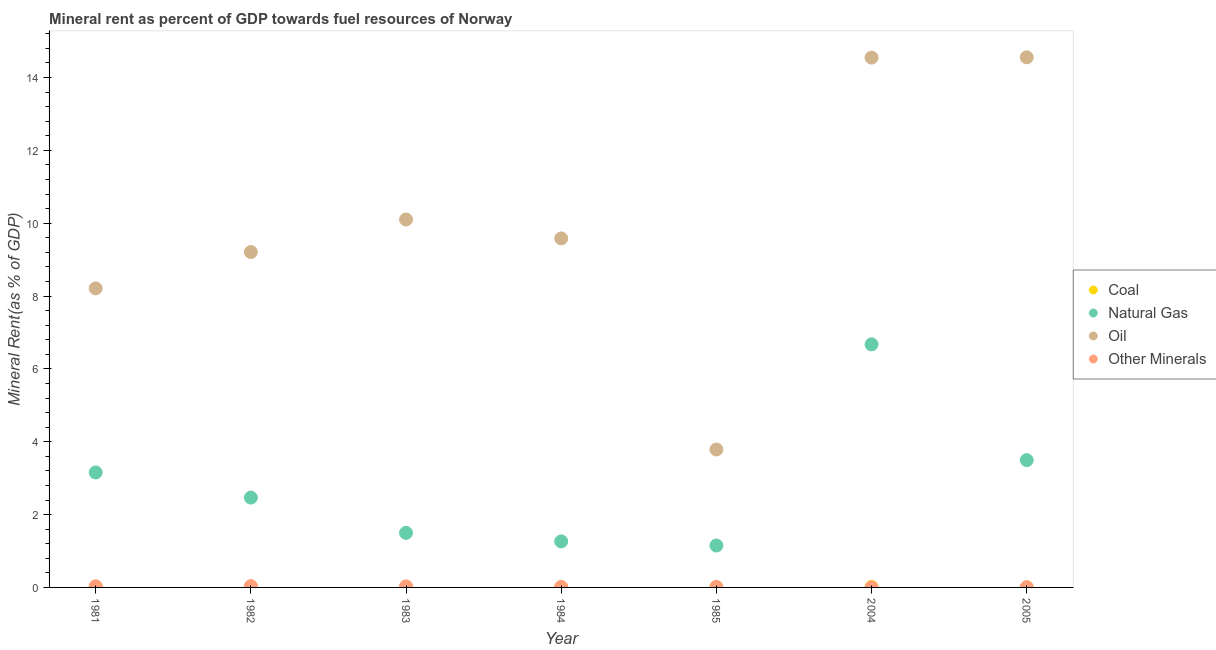What is the coal rent in 1982?
Give a very brief answer. 0.02. Across all years, what is the maximum  rent of other minerals?
Provide a succinct answer. 0.04. Across all years, what is the minimum  rent of other minerals?
Keep it short and to the point. 0. What is the total oil rent in the graph?
Ensure brevity in your answer.  70. What is the difference between the oil rent in 1981 and that in 1984?
Your answer should be very brief. -1.37. What is the difference between the coal rent in 1985 and the  rent of other minerals in 1982?
Give a very brief answer. -0.03. What is the average  rent of other minerals per year?
Ensure brevity in your answer.  0.02. In the year 2004, what is the difference between the oil rent and  rent of other minerals?
Your answer should be compact. 14.55. What is the ratio of the oil rent in 1981 to that in 1984?
Your response must be concise. 0.86. What is the difference between the highest and the second highest  rent of other minerals?
Make the answer very short. 0. What is the difference between the highest and the lowest coal rent?
Offer a terse response. 0.02. In how many years, is the natural gas rent greater than the average natural gas rent taken over all years?
Provide a short and direct response. 3. Is the sum of the natural gas rent in 2004 and 2005 greater than the maximum oil rent across all years?
Your response must be concise. No. Is it the case that in every year, the sum of the  rent of other minerals and natural gas rent is greater than the sum of coal rent and oil rent?
Provide a succinct answer. Yes. Is it the case that in every year, the sum of the coal rent and natural gas rent is greater than the oil rent?
Provide a short and direct response. No. Is the coal rent strictly greater than the natural gas rent over the years?
Provide a succinct answer. No. Is the oil rent strictly less than the natural gas rent over the years?
Give a very brief answer. No. Are the values on the major ticks of Y-axis written in scientific E-notation?
Provide a short and direct response. No. Does the graph contain any zero values?
Make the answer very short. No. Where does the legend appear in the graph?
Ensure brevity in your answer.  Center right. How many legend labels are there?
Give a very brief answer. 4. How are the legend labels stacked?
Offer a very short reply. Vertical. What is the title of the graph?
Your answer should be very brief. Mineral rent as percent of GDP towards fuel resources of Norway. Does "Salary of employees" appear as one of the legend labels in the graph?
Your answer should be compact. No. What is the label or title of the X-axis?
Give a very brief answer. Year. What is the label or title of the Y-axis?
Provide a short and direct response. Mineral Rent(as % of GDP). What is the Mineral Rent(as % of GDP) of Coal in 1981?
Keep it short and to the point. 0.01. What is the Mineral Rent(as % of GDP) in Natural Gas in 1981?
Your answer should be compact. 3.16. What is the Mineral Rent(as % of GDP) of Oil in 1981?
Offer a terse response. 8.21. What is the Mineral Rent(as % of GDP) of Other Minerals in 1981?
Your response must be concise. 0.03. What is the Mineral Rent(as % of GDP) of Coal in 1982?
Your answer should be very brief. 0.02. What is the Mineral Rent(as % of GDP) of Natural Gas in 1982?
Your answer should be very brief. 2.47. What is the Mineral Rent(as % of GDP) in Oil in 1982?
Ensure brevity in your answer.  9.21. What is the Mineral Rent(as % of GDP) in Other Minerals in 1982?
Provide a succinct answer. 0.04. What is the Mineral Rent(as % of GDP) in Coal in 1983?
Your answer should be very brief. 0. What is the Mineral Rent(as % of GDP) in Natural Gas in 1983?
Ensure brevity in your answer.  1.5. What is the Mineral Rent(as % of GDP) in Oil in 1983?
Make the answer very short. 10.1. What is the Mineral Rent(as % of GDP) of Other Minerals in 1983?
Offer a terse response. 0.03. What is the Mineral Rent(as % of GDP) of Coal in 1984?
Provide a succinct answer. 0. What is the Mineral Rent(as % of GDP) of Natural Gas in 1984?
Make the answer very short. 1.26. What is the Mineral Rent(as % of GDP) of Oil in 1984?
Your answer should be compact. 9.58. What is the Mineral Rent(as % of GDP) of Other Minerals in 1984?
Give a very brief answer. 0.02. What is the Mineral Rent(as % of GDP) of Coal in 1985?
Provide a short and direct response. 0. What is the Mineral Rent(as % of GDP) in Natural Gas in 1985?
Ensure brevity in your answer.  1.15. What is the Mineral Rent(as % of GDP) in Oil in 1985?
Your answer should be very brief. 3.79. What is the Mineral Rent(as % of GDP) in Other Minerals in 1985?
Your answer should be compact. 0.01. What is the Mineral Rent(as % of GDP) in Coal in 2004?
Make the answer very short. 0.01. What is the Mineral Rent(as % of GDP) of Natural Gas in 2004?
Provide a succinct answer. 6.67. What is the Mineral Rent(as % of GDP) in Oil in 2004?
Provide a short and direct response. 14.55. What is the Mineral Rent(as % of GDP) in Other Minerals in 2004?
Provide a succinct answer. 0. What is the Mineral Rent(as % of GDP) in Coal in 2005?
Provide a succinct answer. 0. What is the Mineral Rent(as % of GDP) of Natural Gas in 2005?
Offer a very short reply. 3.49. What is the Mineral Rent(as % of GDP) of Oil in 2005?
Your answer should be compact. 14.56. What is the Mineral Rent(as % of GDP) of Other Minerals in 2005?
Your response must be concise. 0.01. Across all years, what is the maximum Mineral Rent(as % of GDP) in Coal?
Provide a succinct answer. 0.02. Across all years, what is the maximum Mineral Rent(as % of GDP) of Natural Gas?
Ensure brevity in your answer.  6.67. Across all years, what is the maximum Mineral Rent(as % of GDP) of Oil?
Provide a succinct answer. 14.56. Across all years, what is the maximum Mineral Rent(as % of GDP) in Other Minerals?
Offer a very short reply. 0.04. Across all years, what is the minimum Mineral Rent(as % of GDP) in Coal?
Ensure brevity in your answer.  0. Across all years, what is the minimum Mineral Rent(as % of GDP) in Natural Gas?
Make the answer very short. 1.15. Across all years, what is the minimum Mineral Rent(as % of GDP) of Oil?
Your answer should be compact. 3.79. Across all years, what is the minimum Mineral Rent(as % of GDP) of Other Minerals?
Your response must be concise. 0. What is the total Mineral Rent(as % of GDP) of Coal in the graph?
Make the answer very short. 0.05. What is the total Mineral Rent(as % of GDP) in Natural Gas in the graph?
Keep it short and to the point. 19.71. What is the total Mineral Rent(as % of GDP) of Oil in the graph?
Keep it short and to the point. 70. What is the total Mineral Rent(as % of GDP) in Other Minerals in the graph?
Make the answer very short. 0.14. What is the difference between the Mineral Rent(as % of GDP) in Coal in 1981 and that in 1982?
Your answer should be compact. -0. What is the difference between the Mineral Rent(as % of GDP) of Natural Gas in 1981 and that in 1982?
Make the answer very short. 0.69. What is the difference between the Mineral Rent(as % of GDP) in Oil in 1981 and that in 1982?
Offer a very short reply. -1. What is the difference between the Mineral Rent(as % of GDP) of Other Minerals in 1981 and that in 1982?
Ensure brevity in your answer.  -0.01. What is the difference between the Mineral Rent(as % of GDP) of Coal in 1981 and that in 1983?
Offer a terse response. 0.01. What is the difference between the Mineral Rent(as % of GDP) of Natural Gas in 1981 and that in 1983?
Your answer should be very brief. 1.66. What is the difference between the Mineral Rent(as % of GDP) in Oil in 1981 and that in 1983?
Offer a terse response. -1.89. What is the difference between the Mineral Rent(as % of GDP) in Other Minerals in 1981 and that in 1983?
Ensure brevity in your answer.  0. What is the difference between the Mineral Rent(as % of GDP) of Coal in 1981 and that in 1984?
Keep it short and to the point. 0.01. What is the difference between the Mineral Rent(as % of GDP) of Natural Gas in 1981 and that in 1984?
Your answer should be compact. 1.89. What is the difference between the Mineral Rent(as % of GDP) in Oil in 1981 and that in 1984?
Keep it short and to the point. -1.37. What is the difference between the Mineral Rent(as % of GDP) of Other Minerals in 1981 and that in 1984?
Your answer should be very brief. 0.02. What is the difference between the Mineral Rent(as % of GDP) of Coal in 1981 and that in 1985?
Your answer should be compact. 0.01. What is the difference between the Mineral Rent(as % of GDP) in Natural Gas in 1981 and that in 1985?
Your response must be concise. 2.01. What is the difference between the Mineral Rent(as % of GDP) in Oil in 1981 and that in 1985?
Your answer should be compact. 4.42. What is the difference between the Mineral Rent(as % of GDP) in Other Minerals in 1981 and that in 1985?
Offer a very short reply. 0.02. What is the difference between the Mineral Rent(as % of GDP) of Coal in 1981 and that in 2004?
Provide a succinct answer. -0. What is the difference between the Mineral Rent(as % of GDP) in Natural Gas in 1981 and that in 2004?
Provide a succinct answer. -3.52. What is the difference between the Mineral Rent(as % of GDP) of Oil in 1981 and that in 2004?
Your response must be concise. -6.34. What is the difference between the Mineral Rent(as % of GDP) in Other Minerals in 1981 and that in 2004?
Offer a terse response. 0.03. What is the difference between the Mineral Rent(as % of GDP) in Coal in 1981 and that in 2005?
Ensure brevity in your answer.  0.01. What is the difference between the Mineral Rent(as % of GDP) of Natural Gas in 1981 and that in 2005?
Give a very brief answer. -0.34. What is the difference between the Mineral Rent(as % of GDP) of Oil in 1981 and that in 2005?
Provide a succinct answer. -6.34. What is the difference between the Mineral Rent(as % of GDP) in Other Minerals in 1981 and that in 2005?
Give a very brief answer. 0.03. What is the difference between the Mineral Rent(as % of GDP) of Coal in 1982 and that in 1983?
Your answer should be compact. 0.01. What is the difference between the Mineral Rent(as % of GDP) of Natural Gas in 1982 and that in 1983?
Your answer should be very brief. 0.97. What is the difference between the Mineral Rent(as % of GDP) of Oil in 1982 and that in 1983?
Your response must be concise. -0.89. What is the difference between the Mineral Rent(as % of GDP) of Other Minerals in 1982 and that in 1983?
Keep it short and to the point. 0.01. What is the difference between the Mineral Rent(as % of GDP) in Coal in 1982 and that in 1984?
Provide a succinct answer. 0.02. What is the difference between the Mineral Rent(as % of GDP) of Natural Gas in 1982 and that in 1984?
Offer a terse response. 1.2. What is the difference between the Mineral Rent(as % of GDP) in Oil in 1982 and that in 1984?
Offer a terse response. -0.37. What is the difference between the Mineral Rent(as % of GDP) in Other Minerals in 1982 and that in 1984?
Ensure brevity in your answer.  0.02. What is the difference between the Mineral Rent(as % of GDP) in Coal in 1982 and that in 1985?
Offer a terse response. 0.01. What is the difference between the Mineral Rent(as % of GDP) of Natural Gas in 1982 and that in 1985?
Your response must be concise. 1.32. What is the difference between the Mineral Rent(as % of GDP) of Oil in 1982 and that in 1985?
Ensure brevity in your answer.  5.42. What is the difference between the Mineral Rent(as % of GDP) in Other Minerals in 1982 and that in 1985?
Keep it short and to the point. 0.02. What is the difference between the Mineral Rent(as % of GDP) in Natural Gas in 1982 and that in 2004?
Keep it short and to the point. -4.21. What is the difference between the Mineral Rent(as % of GDP) in Oil in 1982 and that in 2004?
Make the answer very short. -5.34. What is the difference between the Mineral Rent(as % of GDP) of Other Minerals in 1982 and that in 2004?
Make the answer very short. 0.04. What is the difference between the Mineral Rent(as % of GDP) of Coal in 1982 and that in 2005?
Give a very brief answer. 0.01. What is the difference between the Mineral Rent(as % of GDP) of Natural Gas in 1982 and that in 2005?
Make the answer very short. -1.03. What is the difference between the Mineral Rent(as % of GDP) in Oil in 1982 and that in 2005?
Give a very brief answer. -5.35. What is the difference between the Mineral Rent(as % of GDP) in Other Minerals in 1982 and that in 2005?
Offer a terse response. 0.03. What is the difference between the Mineral Rent(as % of GDP) of Coal in 1983 and that in 1984?
Your answer should be very brief. 0. What is the difference between the Mineral Rent(as % of GDP) of Natural Gas in 1983 and that in 1984?
Make the answer very short. 0.23. What is the difference between the Mineral Rent(as % of GDP) of Oil in 1983 and that in 1984?
Provide a short and direct response. 0.52. What is the difference between the Mineral Rent(as % of GDP) in Other Minerals in 1983 and that in 1984?
Offer a terse response. 0.01. What is the difference between the Mineral Rent(as % of GDP) of Coal in 1983 and that in 1985?
Provide a short and direct response. 0. What is the difference between the Mineral Rent(as % of GDP) of Natural Gas in 1983 and that in 1985?
Give a very brief answer. 0.35. What is the difference between the Mineral Rent(as % of GDP) of Oil in 1983 and that in 1985?
Ensure brevity in your answer.  6.32. What is the difference between the Mineral Rent(as % of GDP) in Other Minerals in 1983 and that in 1985?
Ensure brevity in your answer.  0.01. What is the difference between the Mineral Rent(as % of GDP) in Coal in 1983 and that in 2004?
Your response must be concise. -0.01. What is the difference between the Mineral Rent(as % of GDP) of Natural Gas in 1983 and that in 2004?
Offer a terse response. -5.18. What is the difference between the Mineral Rent(as % of GDP) of Oil in 1983 and that in 2004?
Keep it short and to the point. -4.45. What is the difference between the Mineral Rent(as % of GDP) of Other Minerals in 1983 and that in 2004?
Give a very brief answer. 0.03. What is the difference between the Mineral Rent(as % of GDP) in Coal in 1983 and that in 2005?
Provide a short and direct response. 0. What is the difference between the Mineral Rent(as % of GDP) in Natural Gas in 1983 and that in 2005?
Provide a short and direct response. -2. What is the difference between the Mineral Rent(as % of GDP) of Oil in 1983 and that in 2005?
Offer a very short reply. -4.45. What is the difference between the Mineral Rent(as % of GDP) of Other Minerals in 1983 and that in 2005?
Ensure brevity in your answer.  0.02. What is the difference between the Mineral Rent(as % of GDP) in Coal in 1984 and that in 1985?
Give a very brief answer. -0. What is the difference between the Mineral Rent(as % of GDP) of Natural Gas in 1984 and that in 1985?
Provide a succinct answer. 0.11. What is the difference between the Mineral Rent(as % of GDP) of Oil in 1984 and that in 1985?
Ensure brevity in your answer.  5.8. What is the difference between the Mineral Rent(as % of GDP) in Other Minerals in 1984 and that in 1985?
Make the answer very short. 0. What is the difference between the Mineral Rent(as % of GDP) of Coal in 1984 and that in 2004?
Offer a terse response. -0.01. What is the difference between the Mineral Rent(as % of GDP) in Natural Gas in 1984 and that in 2004?
Give a very brief answer. -5.41. What is the difference between the Mineral Rent(as % of GDP) of Oil in 1984 and that in 2004?
Your response must be concise. -4.97. What is the difference between the Mineral Rent(as % of GDP) in Other Minerals in 1984 and that in 2004?
Give a very brief answer. 0.02. What is the difference between the Mineral Rent(as % of GDP) in Coal in 1984 and that in 2005?
Your answer should be compact. -0. What is the difference between the Mineral Rent(as % of GDP) of Natural Gas in 1984 and that in 2005?
Keep it short and to the point. -2.23. What is the difference between the Mineral Rent(as % of GDP) in Oil in 1984 and that in 2005?
Your response must be concise. -4.97. What is the difference between the Mineral Rent(as % of GDP) in Other Minerals in 1984 and that in 2005?
Keep it short and to the point. 0.01. What is the difference between the Mineral Rent(as % of GDP) in Coal in 1985 and that in 2004?
Provide a succinct answer. -0.01. What is the difference between the Mineral Rent(as % of GDP) of Natural Gas in 1985 and that in 2004?
Provide a succinct answer. -5.52. What is the difference between the Mineral Rent(as % of GDP) in Oil in 1985 and that in 2004?
Offer a terse response. -10.76. What is the difference between the Mineral Rent(as % of GDP) in Other Minerals in 1985 and that in 2004?
Give a very brief answer. 0.01. What is the difference between the Mineral Rent(as % of GDP) of Coal in 1985 and that in 2005?
Your response must be concise. 0. What is the difference between the Mineral Rent(as % of GDP) of Natural Gas in 1985 and that in 2005?
Make the answer very short. -2.34. What is the difference between the Mineral Rent(as % of GDP) of Oil in 1985 and that in 2005?
Offer a terse response. -10.77. What is the difference between the Mineral Rent(as % of GDP) in Other Minerals in 1985 and that in 2005?
Offer a very short reply. 0.01. What is the difference between the Mineral Rent(as % of GDP) of Coal in 2004 and that in 2005?
Your answer should be very brief. 0.01. What is the difference between the Mineral Rent(as % of GDP) in Natural Gas in 2004 and that in 2005?
Your response must be concise. 3.18. What is the difference between the Mineral Rent(as % of GDP) of Oil in 2004 and that in 2005?
Offer a very short reply. -0.01. What is the difference between the Mineral Rent(as % of GDP) in Other Minerals in 2004 and that in 2005?
Make the answer very short. -0.01. What is the difference between the Mineral Rent(as % of GDP) in Coal in 1981 and the Mineral Rent(as % of GDP) in Natural Gas in 1982?
Offer a terse response. -2.45. What is the difference between the Mineral Rent(as % of GDP) in Coal in 1981 and the Mineral Rent(as % of GDP) in Oil in 1982?
Your answer should be very brief. -9.2. What is the difference between the Mineral Rent(as % of GDP) in Coal in 1981 and the Mineral Rent(as % of GDP) in Other Minerals in 1982?
Provide a succinct answer. -0.02. What is the difference between the Mineral Rent(as % of GDP) in Natural Gas in 1981 and the Mineral Rent(as % of GDP) in Oil in 1982?
Your answer should be very brief. -6.05. What is the difference between the Mineral Rent(as % of GDP) in Natural Gas in 1981 and the Mineral Rent(as % of GDP) in Other Minerals in 1982?
Ensure brevity in your answer.  3.12. What is the difference between the Mineral Rent(as % of GDP) in Oil in 1981 and the Mineral Rent(as % of GDP) in Other Minerals in 1982?
Give a very brief answer. 8.17. What is the difference between the Mineral Rent(as % of GDP) in Coal in 1981 and the Mineral Rent(as % of GDP) in Natural Gas in 1983?
Ensure brevity in your answer.  -1.49. What is the difference between the Mineral Rent(as % of GDP) in Coal in 1981 and the Mineral Rent(as % of GDP) in Oil in 1983?
Your answer should be very brief. -10.09. What is the difference between the Mineral Rent(as % of GDP) of Coal in 1981 and the Mineral Rent(as % of GDP) of Other Minerals in 1983?
Keep it short and to the point. -0.02. What is the difference between the Mineral Rent(as % of GDP) in Natural Gas in 1981 and the Mineral Rent(as % of GDP) in Oil in 1983?
Provide a succinct answer. -6.95. What is the difference between the Mineral Rent(as % of GDP) in Natural Gas in 1981 and the Mineral Rent(as % of GDP) in Other Minerals in 1983?
Offer a very short reply. 3.13. What is the difference between the Mineral Rent(as % of GDP) in Oil in 1981 and the Mineral Rent(as % of GDP) in Other Minerals in 1983?
Ensure brevity in your answer.  8.18. What is the difference between the Mineral Rent(as % of GDP) in Coal in 1981 and the Mineral Rent(as % of GDP) in Natural Gas in 1984?
Provide a succinct answer. -1.25. What is the difference between the Mineral Rent(as % of GDP) of Coal in 1981 and the Mineral Rent(as % of GDP) of Oil in 1984?
Make the answer very short. -9.57. What is the difference between the Mineral Rent(as % of GDP) of Coal in 1981 and the Mineral Rent(as % of GDP) of Other Minerals in 1984?
Your answer should be very brief. -0. What is the difference between the Mineral Rent(as % of GDP) in Natural Gas in 1981 and the Mineral Rent(as % of GDP) in Oil in 1984?
Offer a terse response. -6.43. What is the difference between the Mineral Rent(as % of GDP) of Natural Gas in 1981 and the Mineral Rent(as % of GDP) of Other Minerals in 1984?
Provide a succinct answer. 3.14. What is the difference between the Mineral Rent(as % of GDP) of Oil in 1981 and the Mineral Rent(as % of GDP) of Other Minerals in 1984?
Offer a terse response. 8.19. What is the difference between the Mineral Rent(as % of GDP) of Coal in 1981 and the Mineral Rent(as % of GDP) of Natural Gas in 1985?
Your response must be concise. -1.14. What is the difference between the Mineral Rent(as % of GDP) of Coal in 1981 and the Mineral Rent(as % of GDP) of Oil in 1985?
Your response must be concise. -3.77. What is the difference between the Mineral Rent(as % of GDP) of Coal in 1981 and the Mineral Rent(as % of GDP) of Other Minerals in 1985?
Keep it short and to the point. -0. What is the difference between the Mineral Rent(as % of GDP) in Natural Gas in 1981 and the Mineral Rent(as % of GDP) in Oil in 1985?
Ensure brevity in your answer.  -0.63. What is the difference between the Mineral Rent(as % of GDP) of Natural Gas in 1981 and the Mineral Rent(as % of GDP) of Other Minerals in 1985?
Your answer should be very brief. 3.14. What is the difference between the Mineral Rent(as % of GDP) of Oil in 1981 and the Mineral Rent(as % of GDP) of Other Minerals in 1985?
Offer a terse response. 8.2. What is the difference between the Mineral Rent(as % of GDP) in Coal in 1981 and the Mineral Rent(as % of GDP) in Natural Gas in 2004?
Offer a very short reply. -6.66. What is the difference between the Mineral Rent(as % of GDP) of Coal in 1981 and the Mineral Rent(as % of GDP) of Oil in 2004?
Your response must be concise. -14.54. What is the difference between the Mineral Rent(as % of GDP) in Coal in 1981 and the Mineral Rent(as % of GDP) in Other Minerals in 2004?
Provide a succinct answer. 0.01. What is the difference between the Mineral Rent(as % of GDP) in Natural Gas in 1981 and the Mineral Rent(as % of GDP) in Oil in 2004?
Make the answer very short. -11.39. What is the difference between the Mineral Rent(as % of GDP) of Natural Gas in 1981 and the Mineral Rent(as % of GDP) of Other Minerals in 2004?
Offer a terse response. 3.16. What is the difference between the Mineral Rent(as % of GDP) in Oil in 1981 and the Mineral Rent(as % of GDP) in Other Minerals in 2004?
Give a very brief answer. 8.21. What is the difference between the Mineral Rent(as % of GDP) in Coal in 1981 and the Mineral Rent(as % of GDP) in Natural Gas in 2005?
Your answer should be very brief. -3.48. What is the difference between the Mineral Rent(as % of GDP) of Coal in 1981 and the Mineral Rent(as % of GDP) of Oil in 2005?
Make the answer very short. -14.54. What is the difference between the Mineral Rent(as % of GDP) in Coal in 1981 and the Mineral Rent(as % of GDP) in Other Minerals in 2005?
Your response must be concise. 0.01. What is the difference between the Mineral Rent(as % of GDP) in Natural Gas in 1981 and the Mineral Rent(as % of GDP) in Oil in 2005?
Your response must be concise. -11.4. What is the difference between the Mineral Rent(as % of GDP) of Natural Gas in 1981 and the Mineral Rent(as % of GDP) of Other Minerals in 2005?
Keep it short and to the point. 3.15. What is the difference between the Mineral Rent(as % of GDP) of Oil in 1981 and the Mineral Rent(as % of GDP) of Other Minerals in 2005?
Provide a short and direct response. 8.2. What is the difference between the Mineral Rent(as % of GDP) in Coal in 1982 and the Mineral Rent(as % of GDP) in Natural Gas in 1983?
Your answer should be compact. -1.48. What is the difference between the Mineral Rent(as % of GDP) in Coal in 1982 and the Mineral Rent(as % of GDP) in Oil in 1983?
Give a very brief answer. -10.09. What is the difference between the Mineral Rent(as % of GDP) in Coal in 1982 and the Mineral Rent(as % of GDP) in Other Minerals in 1983?
Your answer should be compact. -0.01. What is the difference between the Mineral Rent(as % of GDP) of Natural Gas in 1982 and the Mineral Rent(as % of GDP) of Oil in 1983?
Your response must be concise. -7.64. What is the difference between the Mineral Rent(as % of GDP) in Natural Gas in 1982 and the Mineral Rent(as % of GDP) in Other Minerals in 1983?
Your answer should be compact. 2.44. What is the difference between the Mineral Rent(as % of GDP) of Oil in 1982 and the Mineral Rent(as % of GDP) of Other Minerals in 1983?
Your answer should be compact. 9.18. What is the difference between the Mineral Rent(as % of GDP) in Coal in 1982 and the Mineral Rent(as % of GDP) in Natural Gas in 1984?
Your response must be concise. -1.25. What is the difference between the Mineral Rent(as % of GDP) of Coal in 1982 and the Mineral Rent(as % of GDP) of Oil in 1984?
Your answer should be very brief. -9.57. What is the difference between the Mineral Rent(as % of GDP) of Coal in 1982 and the Mineral Rent(as % of GDP) of Other Minerals in 1984?
Your answer should be very brief. -0. What is the difference between the Mineral Rent(as % of GDP) in Natural Gas in 1982 and the Mineral Rent(as % of GDP) in Oil in 1984?
Ensure brevity in your answer.  -7.12. What is the difference between the Mineral Rent(as % of GDP) of Natural Gas in 1982 and the Mineral Rent(as % of GDP) of Other Minerals in 1984?
Your response must be concise. 2.45. What is the difference between the Mineral Rent(as % of GDP) of Oil in 1982 and the Mineral Rent(as % of GDP) of Other Minerals in 1984?
Offer a terse response. 9.19. What is the difference between the Mineral Rent(as % of GDP) in Coal in 1982 and the Mineral Rent(as % of GDP) in Natural Gas in 1985?
Give a very brief answer. -1.13. What is the difference between the Mineral Rent(as % of GDP) of Coal in 1982 and the Mineral Rent(as % of GDP) of Oil in 1985?
Ensure brevity in your answer.  -3.77. What is the difference between the Mineral Rent(as % of GDP) in Coal in 1982 and the Mineral Rent(as % of GDP) in Other Minerals in 1985?
Keep it short and to the point. 0. What is the difference between the Mineral Rent(as % of GDP) in Natural Gas in 1982 and the Mineral Rent(as % of GDP) in Oil in 1985?
Give a very brief answer. -1.32. What is the difference between the Mineral Rent(as % of GDP) in Natural Gas in 1982 and the Mineral Rent(as % of GDP) in Other Minerals in 1985?
Your response must be concise. 2.45. What is the difference between the Mineral Rent(as % of GDP) in Oil in 1982 and the Mineral Rent(as % of GDP) in Other Minerals in 1985?
Provide a succinct answer. 9.19. What is the difference between the Mineral Rent(as % of GDP) of Coal in 1982 and the Mineral Rent(as % of GDP) of Natural Gas in 2004?
Your response must be concise. -6.66. What is the difference between the Mineral Rent(as % of GDP) of Coal in 1982 and the Mineral Rent(as % of GDP) of Oil in 2004?
Keep it short and to the point. -14.53. What is the difference between the Mineral Rent(as % of GDP) in Coal in 1982 and the Mineral Rent(as % of GDP) in Other Minerals in 2004?
Offer a terse response. 0.01. What is the difference between the Mineral Rent(as % of GDP) of Natural Gas in 1982 and the Mineral Rent(as % of GDP) of Oil in 2004?
Offer a terse response. -12.08. What is the difference between the Mineral Rent(as % of GDP) of Natural Gas in 1982 and the Mineral Rent(as % of GDP) of Other Minerals in 2004?
Offer a very short reply. 2.47. What is the difference between the Mineral Rent(as % of GDP) of Oil in 1982 and the Mineral Rent(as % of GDP) of Other Minerals in 2004?
Offer a very short reply. 9.21. What is the difference between the Mineral Rent(as % of GDP) of Coal in 1982 and the Mineral Rent(as % of GDP) of Natural Gas in 2005?
Give a very brief answer. -3.48. What is the difference between the Mineral Rent(as % of GDP) in Coal in 1982 and the Mineral Rent(as % of GDP) in Oil in 2005?
Your answer should be very brief. -14.54. What is the difference between the Mineral Rent(as % of GDP) in Coal in 1982 and the Mineral Rent(as % of GDP) in Other Minerals in 2005?
Make the answer very short. 0.01. What is the difference between the Mineral Rent(as % of GDP) in Natural Gas in 1982 and the Mineral Rent(as % of GDP) in Oil in 2005?
Ensure brevity in your answer.  -12.09. What is the difference between the Mineral Rent(as % of GDP) of Natural Gas in 1982 and the Mineral Rent(as % of GDP) of Other Minerals in 2005?
Make the answer very short. 2.46. What is the difference between the Mineral Rent(as % of GDP) in Oil in 1982 and the Mineral Rent(as % of GDP) in Other Minerals in 2005?
Offer a very short reply. 9.2. What is the difference between the Mineral Rent(as % of GDP) of Coal in 1983 and the Mineral Rent(as % of GDP) of Natural Gas in 1984?
Your response must be concise. -1.26. What is the difference between the Mineral Rent(as % of GDP) in Coal in 1983 and the Mineral Rent(as % of GDP) in Oil in 1984?
Your answer should be very brief. -9.58. What is the difference between the Mineral Rent(as % of GDP) of Coal in 1983 and the Mineral Rent(as % of GDP) of Other Minerals in 1984?
Your answer should be very brief. -0.01. What is the difference between the Mineral Rent(as % of GDP) in Natural Gas in 1983 and the Mineral Rent(as % of GDP) in Oil in 1984?
Provide a succinct answer. -8.09. What is the difference between the Mineral Rent(as % of GDP) of Natural Gas in 1983 and the Mineral Rent(as % of GDP) of Other Minerals in 1984?
Offer a terse response. 1.48. What is the difference between the Mineral Rent(as % of GDP) of Oil in 1983 and the Mineral Rent(as % of GDP) of Other Minerals in 1984?
Your answer should be very brief. 10.09. What is the difference between the Mineral Rent(as % of GDP) of Coal in 1983 and the Mineral Rent(as % of GDP) of Natural Gas in 1985?
Provide a short and direct response. -1.15. What is the difference between the Mineral Rent(as % of GDP) in Coal in 1983 and the Mineral Rent(as % of GDP) in Oil in 1985?
Make the answer very short. -3.78. What is the difference between the Mineral Rent(as % of GDP) of Coal in 1983 and the Mineral Rent(as % of GDP) of Other Minerals in 1985?
Ensure brevity in your answer.  -0.01. What is the difference between the Mineral Rent(as % of GDP) of Natural Gas in 1983 and the Mineral Rent(as % of GDP) of Oil in 1985?
Your answer should be compact. -2.29. What is the difference between the Mineral Rent(as % of GDP) of Natural Gas in 1983 and the Mineral Rent(as % of GDP) of Other Minerals in 1985?
Offer a terse response. 1.48. What is the difference between the Mineral Rent(as % of GDP) of Oil in 1983 and the Mineral Rent(as % of GDP) of Other Minerals in 1985?
Your response must be concise. 10.09. What is the difference between the Mineral Rent(as % of GDP) of Coal in 1983 and the Mineral Rent(as % of GDP) of Natural Gas in 2004?
Ensure brevity in your answer.  -6.67. What is the difference between the Mineral Rent(as % of GDP) of Coal in 1983 and the Mineral Rent(as % of GDP) of Oil in 2004?
Your answer should be very brief. -14.54. What is the difference between the Mineral Rent(as % of GDP) of Coal in 1983 and the Mineral Rent(as % of GDP) of Other Minerals in 2004?
Make the answer very short. 0. What is the difference between the Mineral Rent(as % of GDP) in Natural Gas in 1983 and the Mineral Rent(as % of GDP) in Oil in 2004?
Offer a terse response. -13.05. What is the difference between the Mineral Rent(as % of GDP) of Natural Gas in 1983 and the Mineral Rent(as % of GDP) of Other Minerals in 2004?
Offer a very short reply. 1.5. What is the difference between the Mineral Rent(as % of GDP) in Oil in 1983 and the Mineral Rent(as % of GDP) in Other Minerals in 2004?
Make the answer very short. 10.1. What is the difference between the Mineral Rent(as % of GDP) of Coal in 1983 and the Mineral Rent(as % of GDP) of Natural Gas in 2005?
Make the answer very short. -3.49. What is the difference between the Mineral Rent(as % of GDP) of Coal in 1983 and the Mineral Rent(as % of GDP) of Oil in 2005?
Your answer should be very brief. -14.55. What is the difference between the Mineral Rent(as % of GDP) of Coal in 1983 and the Mineral Rent(as % of GDP) of Other Minerals in 2005?
Give a very brief answer. -0. What is the difference between the Mineral Rent(as % of GDP) in Natural Gas in 1983 and the Mineral Rent(as % of GDP) in Oil in 2005?
Offer a terse response. -13.06. What is the difference between the Mineral Rent(as % of GDP) in Natural Gas in 1983 and the Mineral Rent(as % of GDP) in Other Minerals in 2005?
Make the answer very short. 1.49. What is the difference between the Mineral Rent(as % of GDP) of Oil in 1983 and the Mineral Rent(as % of GDP) of Other Minerals in 2005?
Offer a very short reply. 10.1. What is the difference between the Mineral Rent(as % of GDP) in Coal in 1984 and the Mineral Rent(as % of GDP) in Natural Gas in 1985?
Ensure brevity in your answer.  -1.15. What is the difference between the Mineral Rent(as % of GDP) in Coal in 1984 and the Mineral Rent(as % of GDP) in Oil in 1985?
Make the answer very short. -3.79. What is the difference between the Mineral Rent(as % of GDP) in Coal in 1984 and the Mineral Rent(as % of GDP) in Other Minerals in 1985?
Keep it short and to the point. -0.01. What is the difference between the Mineral Rent(as % of GDP) of Natural Gas in 1984 and the Mineral Rent(as % of GDP) of Oil in 1985?
Your answer should be very brief. -2.52. What is the difference between the Mineral Rent(as % of GDP) of Natural Gas in 1984 and the Mineral Rent(as % of GDP) of Other Minerals in 1985?
Ensure brevity in your answer.  1.25. What is the difference between the Mineral Rent(as % of GDP) of Oil in 1984 and the Mineral Rent(as % of GDP) of Other Minerals in 1985?
Make the answer very short. 9.57. What is the difference between the Mineral Rent(as % of GDP) of Coal in 1984 and the Mineral Rent(as % of GDP) of Natural Gas in 2004?
Your answer should be very brief. -6.67. What is the difference between the Mineral Rent(as % of GDP) in Coal in 1984 and the Mineral Rent(as % of GDP) in Oil in 2004?
Your answer should be very brief. -14.55. What is the difference between the Mineral Rent(as % of GDP) of Coal in 1984 and the Mineral Rent(as % of GDP) of Other Minerals in 2004?
Ensure brevity in your answer.  -0. What is the difference between the Mineral Rent(as % of GDP) of Natural Gas in 1984 and the Mineral Rent(as % of GDP) of Oil in 2004?
Provide a succinct answer. -13.28. What is the difference between the Mineral Rent(as % of GDP) in Natural Gas in 1984 and the Mineral Rent(as % of GDP) in Other Minerals in 2004?
Give a very brief answer. 1.26. What is the difference between the Mineral Rent(as % of GDP) in Oil in 1984 and the Mineral Rent(as % of GDP) in Other Minerals in 2004?
Keep it short and to the point. 9.58. What is the difference between the Mineral Rent(as % of GDP) of Coal in 1984 and the Mineral Rent(as % of GDP) of Natural Gas in 2005?
Offer a very short reply. -3.49. What is the difference between the Mineral Rent(as % of GDP) in Coal in 1984 and the Mineral Rent(as % of GDP) in Oil in 2005?
Give a very brief answer. -14.56. What is the difference between the Mineral Rent(as % of GDP) of Coal in 1984 and the Mineral Rent(as % of GDP) of Other Minerals in 2005?
Provide a succinct answer. -0.01. What is the difference between the Mineral Rent(as % of GDP) of Natural Gas in 1984 and the Mineral Rent(as % of GDP) of Oil in 2005?
Your answer should be compact. -13.29. What is the difference between the Mineral Rent(as % of GDP) of Natural Gas in 1984 and the Mineral Rent(as % of GDP) of Other Minerals in 2005?
Ensure brevity in your answer.  1.26. What is the difference between the Mineral Rent(as % of GDP) in Oil in 1984 and the Mineral Rent(as % of GDP) in Other Minerals in 2005?
Offer a terse response. 9.58. What is the difference between the Mineral Rent(as % of GDP) in Coal in 1985 and the Mineral Rent(as % of GDP) in Natural Gas in 2004?
Give a very brief answer. -6.67. What is the difference between the Mineral Rent(as % of GDP) in Coal in 1985 and the Mineral Rent(as % of GDP) in Oil in 2004?
Keep it short and to the point. -14.55. What is the difference between the Mineral Rent(as % of GDP) of Coal in 1985 and the Mineral Rent(as % of GDP) of Other Minerals in 2004?
Keep it short and to the point. 0. What is the difference between the Mineral Rent(as % of GDP) in Natural Gas in 1985 and the Mineral Rent(as % of GDP) in Oil in 2004?
Your response must be concise. -13.4. What is the difference between the Mineral Rent(as % of GDP) in Natural Gas in 1985 and the Mineral Rent(as % of GDP) in Other Minerals in 2004?
Make the answer very short. 1.15. What is the difference between the Mineral Rent(as % of GDP) of Oil in 1985 and the Mineral Rent(as % of GDP) of Other Minerals in 2004?
Ensure brevity in your answer.  3.79. What is the difference between the Mineral Rent(as % of GDP) of Coal in 1985 and the Mineral Rent(as % of GDP) of Natural Gas in 2005?
Your response must be concise. -3.49. What is the difference between the Mineral Rent(as % of GDP) of Coal in 1985 and the Mineral Rent(as % of GDP) of Oil in 2005?
Ensure brevity in your answer.  -14.55. What is the difference between the Mineral Rent(as % of GDP) in Coal in 1985 and the Mineral Rent(as % of GDP) in Other Minerals in 2005?
Give a very brief answer. -0. What is the difference between the Mineral Rent(as % of GDP) of Natural Gas in 1985 and the Mineral Rent(as % of GDP) of Oil in 2005?
Make the answer very short. -13.41. What is the difference between the Mineral Rent(as % of GDP) of Natural Gas in 1985 and the Mineral Rent(as % of GDP) of Other Minerals in 2005?
Give a very brief answer. 1.14. What is the difference between the Mineral Rent(as % of GDP) in Oil in 1985 and the Mineral Rent(as % of GDP) in Other Minerals in 2005?
Offer a very short reply. 3.78. What is the difference between the Mineral Rent(as % of GDP) in Coal in 2004 and the Mineral Rent(as % of GDP) in Natural Gas in 2005?
Offer a very short reply. -3.48. What is the difference between the Mineral Rent(as % of GDP) of Coal in 2004 and the Mineral Rent(as % of GDP) of Oil in 2005?
Your answer should be very brief. -14.54. What is the difference between the Mineral Rent(as % of GDP) of Coal in 2004 and the Mineral Rent(as % of GDP) of Other Minerals in 2005?
Your answer should be very brief. 0.01. What is the difference between the Mineral Rent(as % of GDP) of Natural Gas in 2004 and the Mineral Rent(as % of GDP) of Oil in 2005?
Your answer should be compact. -7.88. What is the difference between the Mineral Rent(as % of GDP) in Natural Gas in 2004 and the Mineral Rent(as % of GDP) in Other Minerals in 2005?
Give a very brief answer. 6.67. What is the difference between the Mineral Rent(as % of GDP) in Oil in 2004 and the Mineral Rent(as % of GDP) in Other Minerals in 2005?
Give a very brief answer. 14.54. What is the average Mineral Rent(as % of GDP) in Coal per year?
Provide a succinct answer. 0.01. What is the average Mineral Rent(as % of GDP) in Natural Gas per year?
Provide a short and direct response. 2.82. What is the average Mineral Rent(as % of GDP) of Oil per year?
Offer a very short reply. 10. What is the average Mineral Rent(as % of GDP) in Other Minerals per year?
Your answer should be very brief. 0.02. In the year 1981, what is the difference between the Mineral Rent(as % of GDP) of Coal and Mineral Rent(as % of GDP) of Natural Gas?
Your answer should be very brief. -3.14. In the year 1981, what is the difference between the Mineral Rent(as % of GDP) in Coal and Mineral Rent(as % of GDP) in Oil?
Your answer should be compact. -8.2. In the year 1981, what is the difference between the Mineral Rent(as % of GDP) in Coal and Mineral Rent(as % of GDP) in Other Minerals?
Offer a very short reply. -0.02. In the year 1981, what is the difference between the Mineral Rent(as % of GDP) of Natural Gas and Mineral Rent(as % of GDP) of Oil?
Make the answer very short. -5.05. In the year 1981, what is the difference between the Mineral Rent(as % of GDP) of Natural Gas and Mineral Rent(as % of GDP) of Other Minerals?
Offer a terse response. 3.12. In the year 1981, what is the difference between the Mineral Rent(as % of GDP) of Oil and Mineral Rent(as % of GDP) of Other Minerals?
Your response must be concise. 8.18. In the year 1982, what is the difference between the Mineral Rent(as % of GDP) of Coal and Mineral Rent(as % of GDP) of Natural Gas?
Ensure brevity in your answer.  -2.45. In the year 1982, what is the difference between the Mineral Rent(as % of GDP) of Coal and Mineral Rent(as % of GDP) of Oil?
Provide a succinct answer. -9.19. In the year 1982, what is the difference between the Mineral Rent(as % of GDP) in Coal and Mineral Rent(as % of GDP) in Other Minerals?
Your answer should be compact. -0.02. In the year 1982, what is the difference between the Mineral Rent(as % of GDP) of Natural Gas and Mineral Rent(as % of GDP) of Oil?
Offer a terse response. -6.74. In the year 1982, what is the difference between the Mineral Rent(as % of GDP) in Natural Gas and Mineral Rent(as % of GDP) in Other Minerals?
Your response must be concise. 2.43. In the year 1982, what is the difference between the Mineral Rent(as % of GDP) of Oil and Mineral Rent(as % of GDP) of Other Minerals?
Your answer should be very brief. 9.17. In the year 1983, what is the difference between the Mineral Rent(as % of GDP) of Coal and Mineral Rent(as % of GDP) of Natural Gas?
Keep it short and to the point. -1.49. In the year 1983, what is the difference between the Mineral Rent(as % of GDP) of Coal and Mineral Rent(as % of GDP) of Oil?
Offer a terse response. -10.1. In the year 1983, what is the difference between the Mineral Rent(as % of GDP) in Coal and Mineral Rent(as % of GDP) in Other Minerals?
Offer a very short reply. -0.02. In the year 1983, what is the difference between the Mineral Rent(as % of GDP) in Natural Gas and Mineral Rent(as % of GDP) in Oil?
Keep it short and to the point. -8.6. In the year 1983, what is the difference between the Mineral Rent(as % of GDP) of Natural Gas and Mineral Rent(as % of GDP) of Other Minerals?
Provide a short and direct response. 1.47. In the year 1983, what is the difference between the Mineral Rent(as % of GDP) of Oil and Mineral Rent(as % of GDP) of Other Minerals?
Offer a terse response. 10.07. In the year 1984, what is the difference between the Mineral Rent(as % of GDP) in Coal and Mineral Rent(as % of GDP) in Natural Gas?
Give a very brief answer. -1.26. In the year 1984, what is the difference between the Mineral Rent(as % of GDP) in Coal and Mineral Rent(as % of GDP) in Oil?
Offer a very short reply. -9.58. In the year 1984, what is the difference between the Mineral Rent(as % of GDP) in Coal and Mineral Rent(as % of GDP) in Other Minerals?
Provide a short and direct response. -0.02. In the year 1984, what is the difference between the Mineral Rent(as % of GDP) of Natural Gas and Mineral Rent(as % of GDP) of Oil?
Ensure brevity in your answer.  -8.32. In the year 1984, what is the difference between the Mineral Rent(as % of GDP) in Natural Gas and Mineral Rent(as % of GDP) in Other Minerals?
Make the answer very short. 1.25. In the year 1984, what is the difference between the Mineral Rent(as % of GDP) of Oil and Mineral Rent(as % of GDP) of Other Minerals?
Offer a terse response. 9.57. In the year 1985, what is the difference between the Mineral Rent(as % of GDP) in Coal and Mineral Rent(as % of GDP) in Natural Gas?
Ensure brevity in your answer.  -1.15. In the year 1985, what is the difference between the Mineral Rent(as % of GDP) in Coal and Mineral Rent(as % of GDP) in Oil?
Give a very brief answer. -3.78. In the year 1985, what is the difference between the Mineral Rent(as % of GDP) of Coal and Mineral Rent(as % of GDP) of Other Minerals?
Your answer should be compact. -0.01. In the year 1985, what is the difference between the Mineral Rent(as % of GDP) of Natural Gas and Mineral Rent(as % of GDP) of Oil?
Your response must be concise. -2.64. In the year 1985, what is the difference between the Mineral Rent(as % of GDP) in Natural Gas and Mineral Rent(as % of GDP) in Other Minerals?
Offer a terse response. 1.14. In the year 1985, what is the difference between the Mineral Rent(as % of GDP) in Oil and Mineral Rent(as % of GDP) in Other Minerals?
Provide a short and direct response. 3.77. In the year 2004, what is the difference between the Mineral Rent(as % of GDP) of Coal and Mineral Rent(as % of GDP) of Natural Gas?
Ensure brevity in your answer.  -6.66. In the year 2004, what is the difference between the Mineral Rent(as % of GDP) of Coal and Mineral Rent(as % of GDP) of Oil?
Make the answer very short. -14.53. In the year 2004, what is the difference between the Mineral Rent(as % of GDP) in Coal and Mineral Rent(as % of GDP) in Other Minerals?
Your answer should be compact. 0.01. In the year 2004, what is the difference between the Mineral Rent(as % of GDP) in Natural Gas and Mineral Rent(as % of GDP) in Oil?
Provide a succinct answer. -7.87. In the year 2004, what is the difference between the Mineral Rent(as % of GDP) in Natural Gas and Mineral Rent(as % of GDP) in Other Minerals?
Offer a very short reply. 6.67. In the year 2004, what is the difference between the Mineral Rent(as % of GDP) of Oil and Mineral Rent(as % of GDP) of Other Minerals?
Provide a succinct answer. 14.55. In the year 2005, what is the difference between the Mineral Rent(as % of GDP) in Coal and Mineral Rent(as % of GDP) in Natural Gas?
Ensure brevity in your answer.  -3.49. In the year 2005, what is the difference between the Mineral Rent(as % of GDP) in Coal and Mineral Rent(as % of GDP) in Oil?
Your answer should be very brief. -14.55. In the year 2005, what is the difference between the Mineral Rent(as % of GDP) of Coal and Mineral Rent(as % of GDP) of Other Minerals?
Offer a very short reply. -0. In the year 2005, what is the difference between the Mineral Rent(as % of GDP) in Natural Gas and Mineral Rent(as % of GDP) in Oil?
Your answer should be very brief. -11.06. In the year 2005, what is the difference between the Mineral Rent(as % of GDP) of Natural Gas and Mineral Rent(as % of GDP) of Other Minerals?
Offer a very short reply. 3.49. In the year 2005, what is the difference between the Mineral Rent(as % of GDP) of Oil and Mineral Rent(as % of GDP) of Other Minerals?
Keep it short and to the point. 14.55. What is the ratio of the Mineral Rent(as % of GDP) of Coal in 1981 to that in 1982?
Ensure brevity in your answer.  0.82. What is the ratio of the Mineral Rent(as % of GDP) of Natural Gas in 1981 to that in 1982?
Give a very brief answer. 1.28. What is the ratio of the Mineral Rent(as % of GDP) of Oil in 1981 to that in 1982?
Provide a succinct answer. 0.89. What is the ratio of the Mineral Rent(as % of GDP) in Other Minerals in 1981 to that in 1982?
Make the answer very short. 0.86. What is the ratio of the Mineral Rent(as % of GDP) of Natural Gas in 1981 to that in 1983?
Give a very brief answer. 2.11. What is the ratio of the Mineral Rent(as % of GDP) of Oil in 1981 to that in 1983?
Keep it short and to the point. 0.81. What is the ratio of the Mineral Rent(as % of GDP) in Other Minerals in 1981 to that in 1983?
Your answer should be compact. 1.09. What is the ratio of the Mineral Rent(as % of GDP) in Coal in 1981 to that in 1984?
Make the answer very short. 71.41. What is the ratio of the Mineral Rent(as % of GDP) in Natural Gas in 1981 to that in 1984?
Ensure brevity in your answer.  2.5. What is the ratio of the Mineral Rent(as % of GDP) in Oil in 1981 to that in 1984?
Your answer should be compact. 0.86. What is the ratio of the Mineral Rent(as % of GDP) in Other Minerals in 1981 to that in 1984?
Your answer should be compact. 1.96. What is the ratio of the Mineral Rent(as % of GDP) in Coal in 1981 to that in 1985?
Provide a short and direct response. 5.09. What is the ratio of the Mineral Rent(as % of GDP) in Natural Gas in 1981 to that in 1985?
Offer a terse response. 2.74. What is the ratio of the Mineral Rent(as % of GDP) in Oil in 1981 to that in 1985?
Give a very brief answer. 2.17. What is the ratio of the Mineral Rent(as % of GDP) in Other Minerals in 1981 to that in 1985?
Offer a terse response. 2.19. What is the ratio of the Mineral Rent(as % of GDP) in Coal in 1981 to that in 2004?
Make the answer very short. 0.88. What is the ratio of the Mineral Rent(as % of GDP) in Natural Gas in 1981 to that in 2004?
Your answer should be compact. 0.47. What is the ratio of the Mineral Rent(as % of GDP) in Oil in 1981 to that in 2004?
Offer a very short reply. 0.56. What is the ratio of the Mineral Rent(as % of GDP) in Other Minerals in 1981 to that in 2004?
Provide a short and direct response. 53.14. What is the ratio of the Mineral Rent(as % of GDP) in Coal in 1981 to that in 2005?
Give a very brief answer. 8.35. What is the ratio of the Mineral Rent(as % of GDP) of Natural Gas in 1981 to that in 2005?
Provide a short and direct response. 0.9. What is the ratio of the Mineral Rent(as % of GDP) of Oil in 1981 to that in 2005?
Your answer should be very brief. 0.56. What is the ratio of the Mineral Rent(as % of GDP) in Other Minerals in 1981 to that in 2005?
Provide a succinct answer. 5.17. What is the ratio of the Mineral Rent(as % of GDP) of Coal in 1982 to that in 1983?
Give a very brief answer. 3.53. What is the ratio of the Mineral Rent(as % of GDP) in Natural Gas in 1982 to that in 1983?
Provide a succinct answer. 1.65. What is the ratio of the Mineral Rent(as % of GDP) in Oil in 1982 to that in 1983?
Make the answer very short. 0.91. What is the ratio of the Mineral Rent(as % of GDP) of Other Minerals in 1982 to that in 1983?
Keep it short and to the point. 1.26. What is the ratio of the Mineral Rent(as % of GDP) of Coal in 1982 to that in 1984?
Offer a terse response. 86.99. What is the ratio of the Mineral Rent(as % of GDP) in Natural Gas in 1982 to that in 1984?
Ensure brevity in your answer.  1.95. What is the ratio of the Mineral Rent(as % of GDP) of Oil in 1982 to that in 1984?
Keep it short and to the point. 0.96. What is the ratio of the Mineral Rent(as % of GDP) of Other Minerals in 1982 to that in 1984?
Ensure brevity in your answer.  2.27. What is the ratio of the Mineral Rent(as % of GDP) of Coal in 1982 to that in 1985?
Make the answer very short. 6.2. What is the ratio of the Mineral Rent(as % of GDP) in Natural Gas in 1982 to that in 1985?
Offer a terse response. 2.14. What is the ratio of the Mineral Rent(as % of GDP) in Oil in 1982 to that in 1985?
Keep it short and to the point. 2.43. What is the ratio of the Mineral Rent(as % of GDP) of Other Minerals in 1982 to that in 1985?
Make the answer very short. 2.53. What is the ratio of the Mineral Rent(as % of GDP) of Coal in 1982 to that in 2004?
Keep it short and to the point. 1.07. What is the ratio of the Mineral Rent(as % of GDP) of Natural Gas in 1982 to that in 2004?
Give a very brief answer. 0.37. What is the ratio of the Mineral Rent(as % of GDP) of Oil in 1982 to that in 2004?
Provide a short and direct response. 0.63. What is the ratio of the Mineral Rent(as % of GDP) in Other Minerals in 1982 to that in 2004?
Make the answer very short. 61.45. What is the ratio of the Mineral Rent(as % of GDP) of Coal in 1982 to that in 2005?
Provide a short and direct response. 10.18. What is the ratio of the Mineral Rent(as % of GDP) of Natural Gas in 1982 to that in 2005?
Keep it short and to the point. 0.71. What is the ratio of the Mineral Rent(as % of GDP) in Oil in 1982 to that in 2005?
Your response must be concise. 0.63. What is the ratio of the Mineral Rent(as % of GDP) of Other Minerals in 1982 to that in 2005?
Ensure brevity in your answer.  5.98. What is the ratio of the Mineral Rent(as % of GDP) in Coal in 1983 to that in 1984?
Your answer should be compact. 24.62. What is the ratio of the Mineral Rent(as % of GDP) in Natural Gas in 1983 to that in 1984?
Make the answer very short. 1.18. What is the ratio of the Mineral Rent(as % of GDP) of Oil in 1983 to that in 1984?
Ensure brevity in your answer.  1.05. What is the ratio of the Mineral Rent(as % of GDP) of Other Minerals in 1983 to that in 1984?
Provide a succinct answer. 1.8. What is the ratio of the Mineral Rent(as % of GDP) of Coal in 1983 to that in 1985?
Offer a very short reply. 1.75. What is the ratio of the Mineral Rent(as % of GDP) in Natural Gas in 1983 to that in 1985?
Your response must be concise. 1.3. What is the ratio of the Mineral Rent(as % of GDP) of Oil in 1983 to that in 1985?
Offer a terse response. 2.67. What is the ratio of the Mineral Rent(as % of GDP) in Other Minerals in 1983 to that in 1985?
Your response must be concise. 2.01. What is the ratio of the Mineral Rent(as % of GDP) in Coal in 1983 to that in 2004?
Provide a succinct answer. 0.3. What is the ratio of the Mineral Rent(as % of GDP) of Natural Gas in 1983 to that in 2004?
Your answer should be compact. 0.22. What is the ratio of the Mineral Rent(as % of GDP) of Oil in 1983 to that in 2004?
Keep it short and to the point. 0.69. What is the ratio of the Mineral Rent(as % of GDP) in Other Minerals in 1983 to that in 2004?
Provide a succinct answer. 48.8. What is the ratio of the Mineral Rent(as % of GDP) of Coal in 1983 to that in 2005?
Make the answer very short. 2.88. What is the ratio of the Mineral Rent(as % of GDP) in Natural Gas in 1983 to that in 2005?
Make the answer very short. 0.43. What is the ratio of the Mineral Rent(as % of GDP) in Oil in 1983 to that in 2005?
Keep it short and to the point. 0.69. What is the ratio of the Mineral Rent(as % of GDP) in Other Minerals in 1983 to that in 2005?
Give a very brief answer. 4.75. What is the ratio of the Mineral Rent(as % of GDP) in Coal in 1984 to that in 1985?
Give a very brief answer. 0.07. What is the ratio of the Mineral Rent(as % of GDP) in Natural Gas in 1984 to that in 1985?
Your answer should be very brief. 1.1. What is the ratio of the Mineral Rent(as % of GDP) of Oil in 1984 to that in 1985?
Provide a succinct answer. 2.53. What is the ratio of the Mineral Rent(as % of GDP) of Other Minerals in 1984 to that in 1985?
Offer a terse response. 1.11. What is the ratio of the Mineral Rent(as % of GDP) in Coal in 1984 to that in 2004?
Keep it short and to the point. 0.01. What is the ratio of the Mineral Rent(as % of GDP) of Natural Gas in 1984 to that in 2004?
Provide a short and direct response. 0.19. What is the ratio of the Mineral Rent(as % of GDP) in Oil in 1984 to that in 2004?
Make the answer very short. 0.66. What is the ratio of the Mineral Rent(as % of GDP) in Other Minerals in 1984 to that in 2004?
Offer a very short reply. 27.05. What is the ratio of the Mineral Rent(as % of GDP) of Coal in 1984 to that in 2005?
Your answer should be very brief. 0.12. What is the ratio of the Mineral Rent(as % of GDP) of Natural Gas in 1984 to that in 2005?
Make the answer very short. 0.36. What is the ratio of the Mineral Rent(as % of GDP) in Oil in 1984 to that in 2005?
Offer a terse response. 0.66. What is the ratio of the Mineral Rent(as % of GDP) in Other Minerals in 1984 to that in 2005?
Your answer should be compact. 2.63. What is the ratio of the Mineral Rent(as % of GDP) in Coal in 1985 to that in 2004?
Ensure brevity in your answer.  0.17. What is the ratio of the Mineral Rent(as % of GDP) of Natural Gas in 1985 to that in 2004?
Offer a terse response. 0.17. What is the ratio of the Mineral Rent(as % of GDP) of Oil in 1985 to that in 2004?
Keep it short and to the point. 0.26. What is the ratio of the Mineral Rent(as % of GDP) in Other Minerals in 1985 to that in 2004?
Keep it short and to the point. 24.32. What is the ratio of the Mineral Rent(as % of GDP) in Coal in 1985 to that in 2005?
Ensure brevity in your answer.  1.64. What is the ratio of the Mineral Rent(as % of GDP) in Natural Gas in 1985 to that in 2005?
Offer a very short reply. 0.33. What is the ratio of the Mineral Rent(as % of GDP) of Oil in 1985 to that in 2005?
Your response must be concise. 0.26. What is the ratio of the Mineral Rent(as % of GDP) in Other Minerals in 1985 to that in 2005?
Ensure brevity in your answer.  2.37. What is the ratio of the Mineral Rent(as % of GDP) of Coal in 2004 to that in 2005?
Offer a very short reply. 9.5. What is the ratio of the Mineral Rent(as % of GDP) in Natural Gas in 2004 to that in 2005?
Keep it short and to the point. 1.91. What is the ratio of the Mineral Rent(as % of GDP) of Other Minerals in 2004 to that in 2005?
Give a very brief answer. 0.1. What is the difference between the highest and the second highest Mineral Rent(as % of GDP) of Natural Gas?
Offer a very short reply. 3.18. What is the difference between the highest and the second highest Mineral Rent(as % of GDP) of Oil?
Offer a very short reply. 0.01. What is the difference between the highest and the second highest Mineral Rent(as % of GDP) in Other Minerals?
Give a very brief answer. 0.01. What is the difference between the highest and the lowest Mineral Rent(as % of GDP) of Coal?
Offer a terse response. 0.02. What is the difference between the highest and the lowest Mineral Rent(as % of GDP) in Natural Gas?
Make the answer very short. 5.52. What is the difference between the highest and the lowest Mineral Rent(as % of GDP) of Oil?
Provide a short and direct response. 10.77. What is the difference between the highest and the lowest Mineral Rent(as % of GDP) in Other Minerals?
Keep it short and to the point. 0.04. 